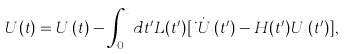<formula> <loc_0><loc_0><loc_500><loc_500>U ( t ) = U _ { t } ( t ) - \int _ { 0 } ^ { t } d t ^ { \prime } L ( t ^ { \prime } ) [ i \dot { U } _ { t } ( t ^ { \prime } ) - H ( t ^ { \prime } ) U _ { t } ( t ^ { \prime } ) ] ,</formula> 